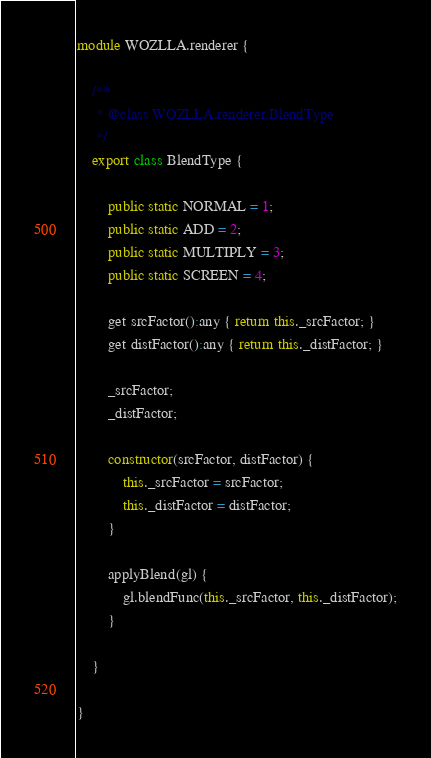Convert code to text. <code><loc_0><loc_0><loc_500><loc_500><_TypeScript_>module WOZLLA.renderer {

    /**
     * @class WOZLLA.renderer.BlendType
     */
    export class BlendType {

        public static NORMAL = 1;
        public static ADD = 2;
        public static MULTIPLY = 3;
        public static SCREEN = 4;

        get srcFactor():any { return this._srcFactor; }
        get distFactor():any { return this._distFactor; }

        _srcFactor;
        _distFactor;

        constructor(srcFactor, distFactor) {
            this._srcFactor = srcFactor;
            this._distFactor = distFactor;
        }

        applyBlend(gl) {
            gl.blendFunc(this._srcFactor, this._distFactor);
        }

    }

}</code> 